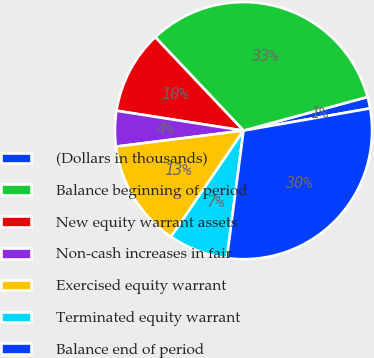Convert chart to OTSL. <chart><loc_0><loc_0><loc_500><loc_500><pie_chart><fcel>(Dollars in thousands)<fcel>Balance beginning of period<fcel>New equity warrant assets<fcel>Non-cash increases in fair<fcel>Exercised equity warrant<fcel>Terminated equity warrant<fcel>Balance end of period<nl><fcel>1.45%<fcel>32.83%<fcel>10.48%<fcel>4.46%<fcel>13.48%<fcel>7.47%<fcel>29.83%<nl></chart> 